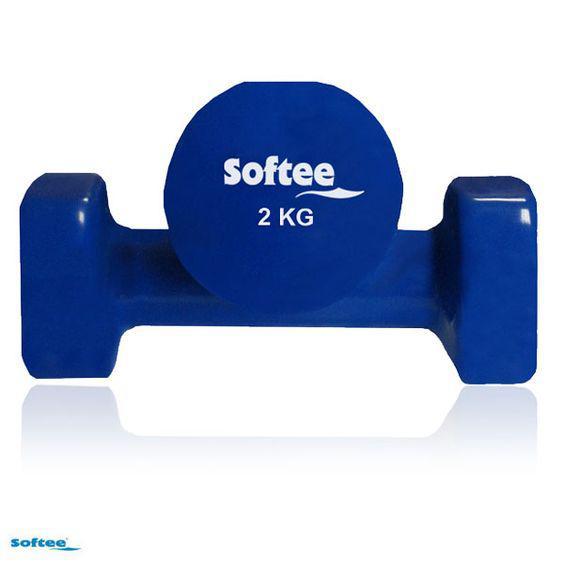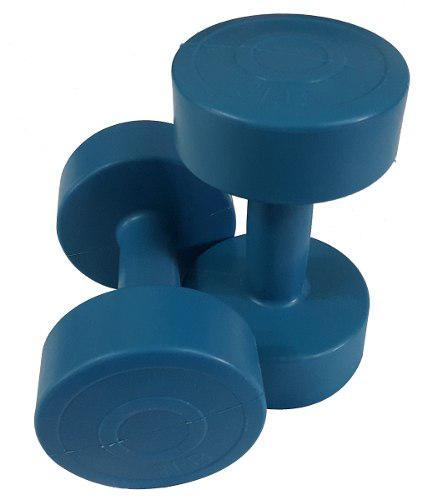The first image is the image on the left, the second image is the image on the right. Evaluate the accuracy of this statement regarding the images: "All of the weights in the image on the right are completely blue in color.". Is it true? Answer yes or no. Yes. The first image is the image on the left, the second image is the image on the right. Assess this claim about the two images: "A row of six dumbbells appears in one image, arranged in a sequence from least to most weight.". Correct or not? Answer yes or no. No. 